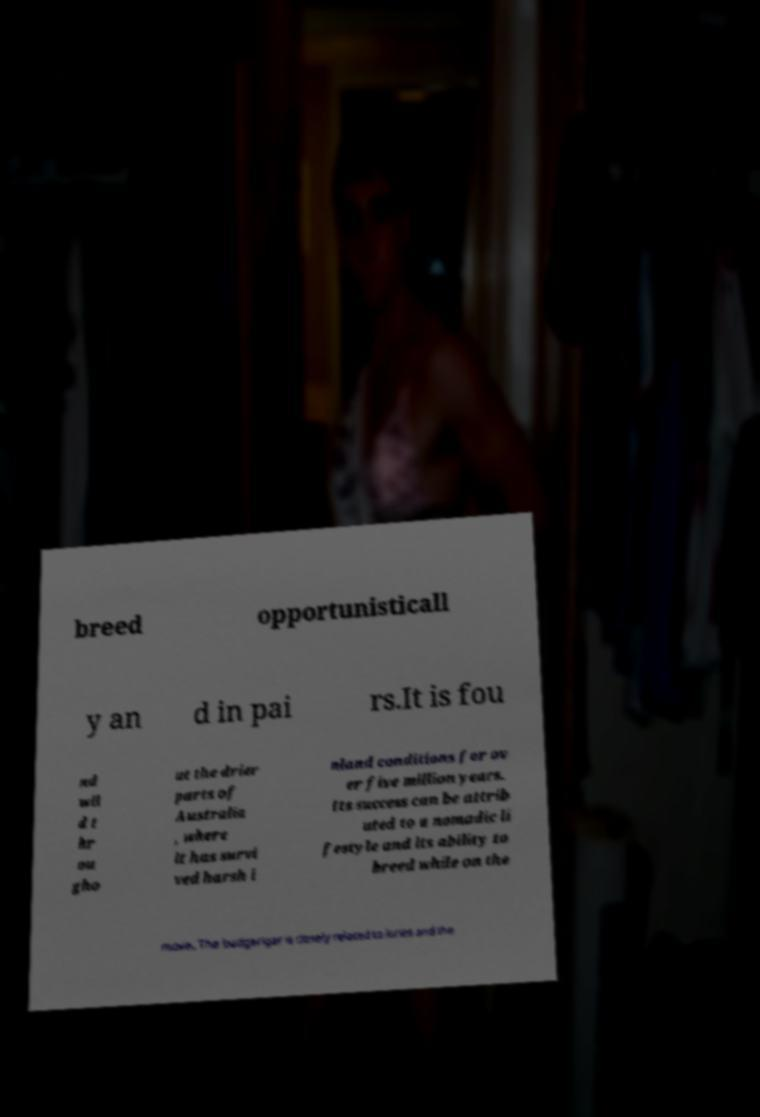Please read and relay the text visible in this image. What does it say? breed opportunisticall y an d in pai rs.It is fou nd wil d t hr ou gho ut the drier parts of Australia , where it has survi ved harsh i nland conditions for ov er five million years. Its success can be attrib uted to a nomadic li festyle and its ability to breed while on the move. The budgerigar is closely related to lories and the 